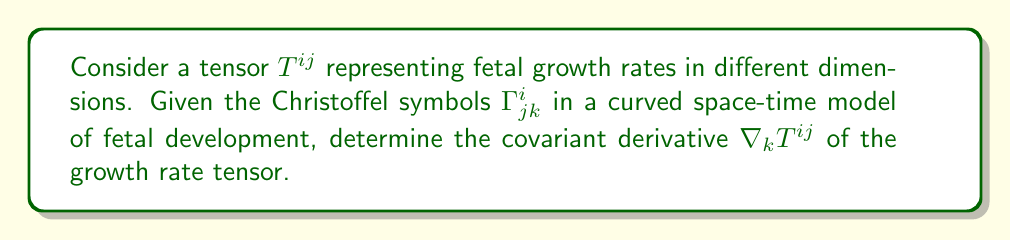Can you answer this question? To find the covariant derivative of the tensor $T^{ij}$, we follow these steps:

1. Recall the formula for the covariant derivative of a contravariant tensor:

   $$\nabla_k T^{ij} = \partial_k T^{ij} + \Gamma^i_{kl}T^{lj} + \Gamma^j_{kl}T^{il}$$

2. We need to calculate three terms:
   a) The partial derivative $\partial_k T^{ij}$
   b) The term involving the first Christoffel symbol: $\Gamma^i_{kl}T^{lj}$
   c) The term involving the second Christoffel symbol: $\Gamma^j_{kl}T^{il}$

3. For the partial derivative, we assume $\partial_k T^{ij} = \frac{\partial T^{ij}}{\partial x^k}$.

4. For the second term, we sum over the repeated index $l$:
   $$\Gamma^i_{kl}T^{lj} = \Gamma^i_{k1}T^{1j} + \Gamma^i_{k2}T^{2j} + \Gamma^i_{k3}T^{3j} + \Gamma^i_{k4}T^{4j}$$

5. Similarly, for the third term:
   $$\Gamma^j_{kl}T^{il} = \Gamma^j_{k1}T^{i1} + \Gamma^j_{k2}T^{i2} + \Gamma^j_{k3}T^{i3} + \Gamma^j_{k4}T^{i4}$$

6. Combining all terms, we get the final expression for the covariant derivative:

   $$\nabla_k T^{ij} = \frac{\partial T^{ij}}{\partial x^k} + \sum_{l=1}^4 (\Gamma^i_{kl}T^{lj} + \Gamma^j_{kl}T^{il})$$

This expression represents how the fetal growth rate tensor changes in the curved space-time model of fetal development, taking into account both the direct rate of change and the effects of the curved geometry.
Answer: $$\nabla_k T^{ij} = \frac{\partial T^{ij}}{\partial x^k} + \sum_{l=1}^4 (\Gamma^i_{kl}T^{lj} + \Gamma^j_{kl}T^{il})$$ 